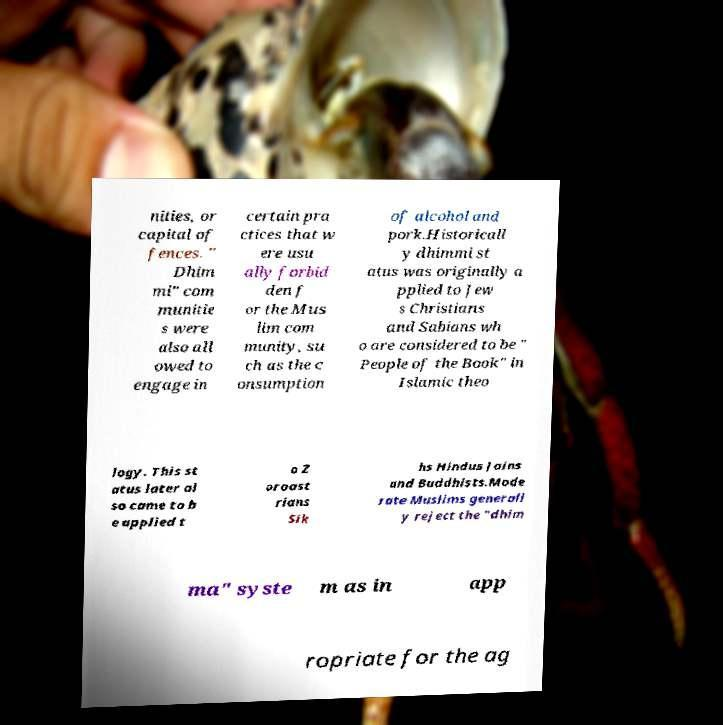Please read and relay the text visible in this image. What does it say? nities, or capital of fences. " Dhim mi" com munitie s were also all owed to engage in certain pra ctices that w ere usu ally forbid den f or the Mus lim com munity, su ch as the c onsumption of alcohol and pork.Historicall y dhimmi st atus was originally a pplied to Jew s Christians and Sabians wh o are considered to be " People of the Book" in Islamic theo logy. This st atus later al so came to b e applied t o Z oroast rians Sik hs Hindus Jains and Buddhists.Mode rate Muslims generall y reject the "dhim ma" syste m as in app ropriate for the ag 